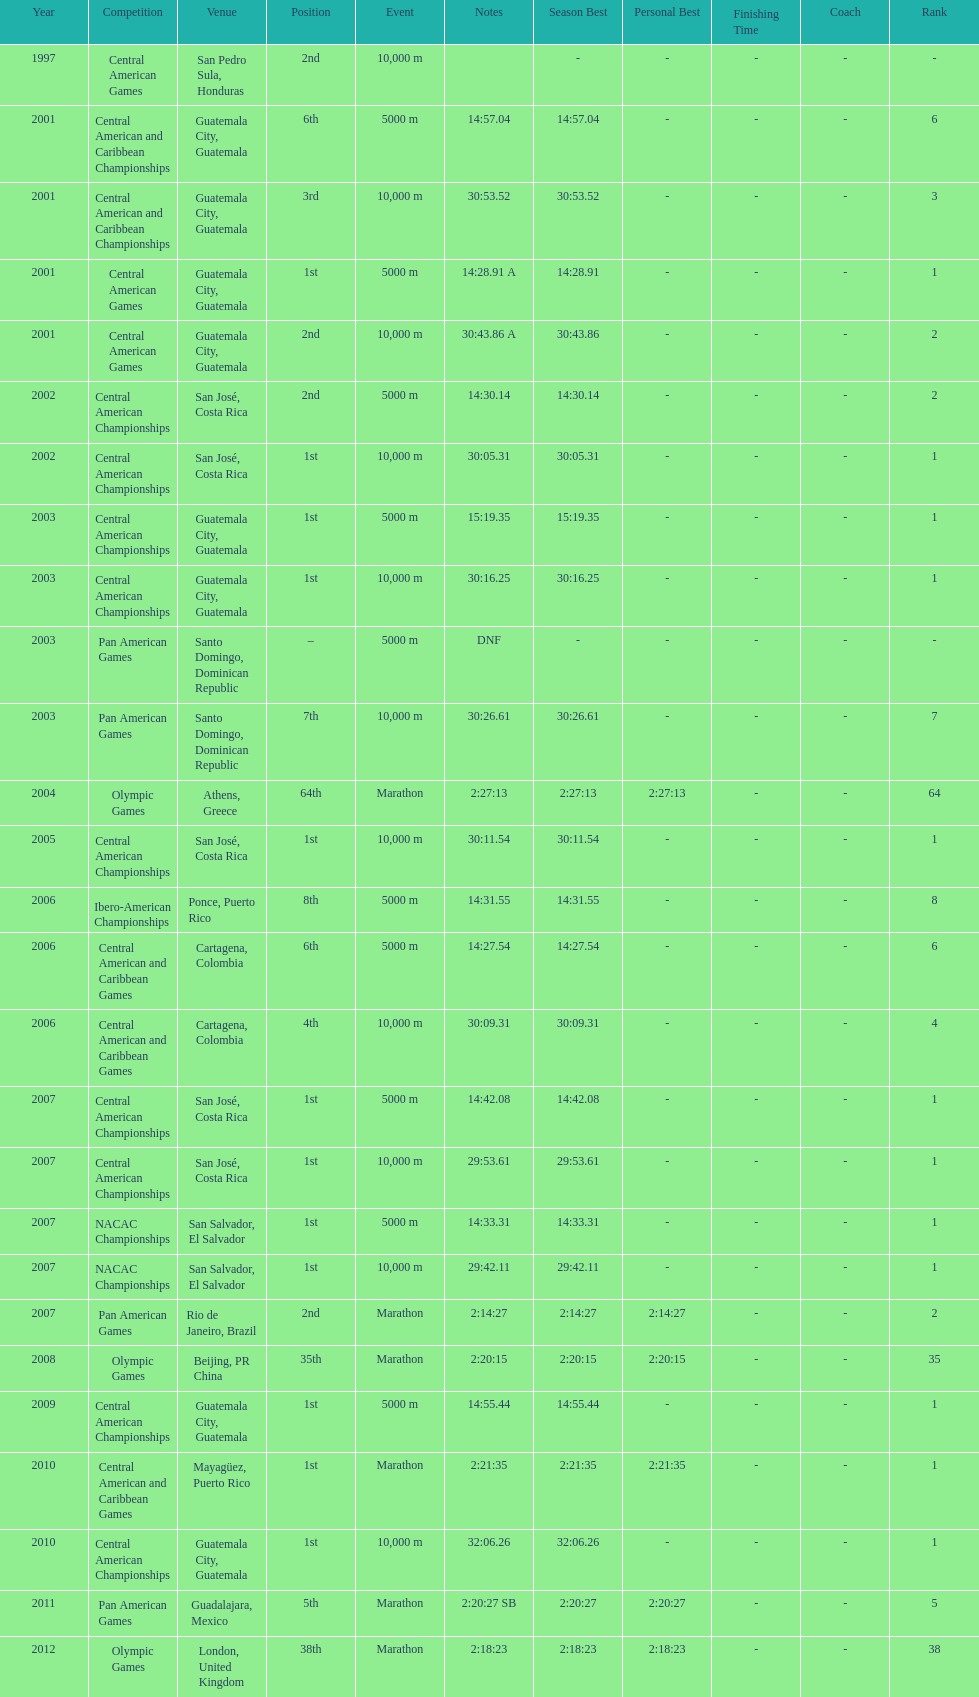Where was the only 64th position held? Athens, Greece. 